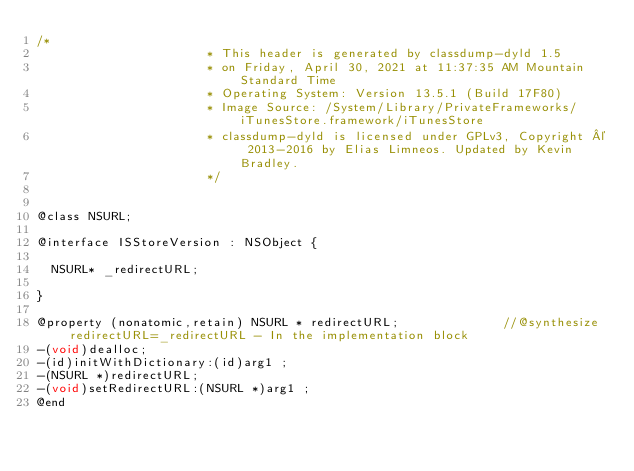<code> <loc_0><loc_0><loc_500><loc_500><_C_>/*
                       * This header is generated by classdump-dyld 1.5
                       * on Friday, April 30, 2021 at 11:37:35 AM Mountain Standard Time
                       * Operating System: Version 13.5.1 (Build 17F80)
                       * Image Source: /System/Library/PrivateFrameworks/iTunesStore.framework/iTunesStore
                       * classdump-dyld is licensed under GPLv3, Copyright © 2013-2016 by Elias Limneos. Updated by Kevin Bradley.
                       */


@class NSURL;

@interface ISStoreVersion : NSObject {

	NSURL* _redirectURL;

}

@property (nonatomic,retain) NSURL * redirectURL;              //@synthesize redirectURL=_redirectURL - In the implementation block
-(void)dealloc;
-(id)initWithDictionary:(id)arg1 ;
-(NSURL *)redirectURL;
-(void)setRedirectURL:(NSURL *)arg1 ;
@end

</code> 